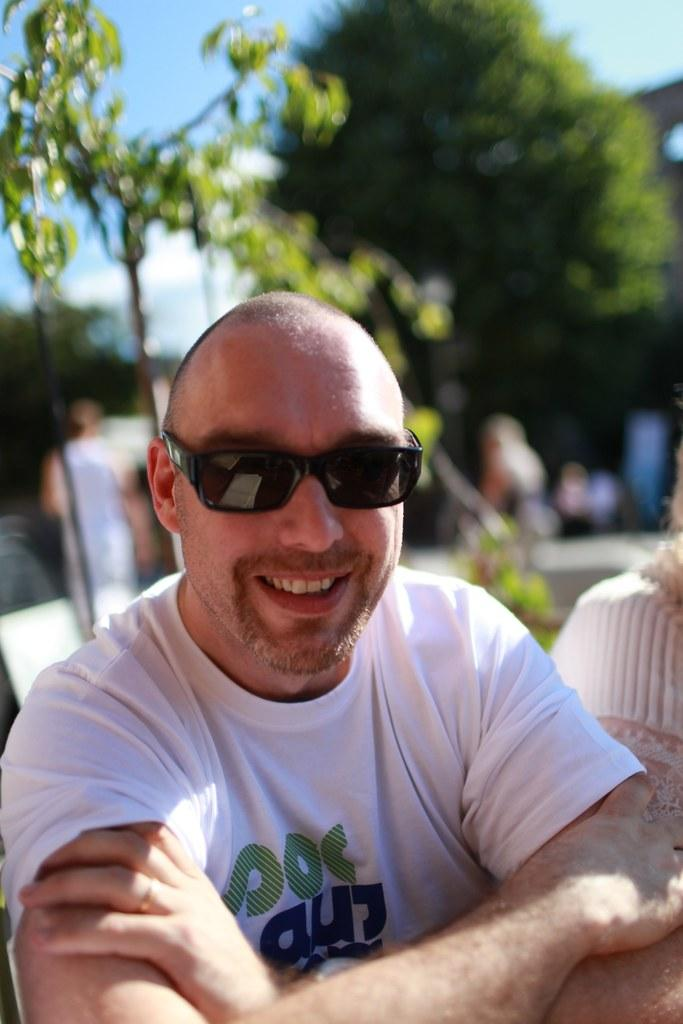Who or what is the main subject of the image? There is a person in the image. What can be observed about the person's appearance? The person is wearing spectacles. What type of natural environment is visible in the background of the image? There are trees in the background of the image. What else can be seen in the background of the image? The sky is visible in the background of the image. What type of milk is being used to put out the fire in the image? There is no fire or milk present in the image. 